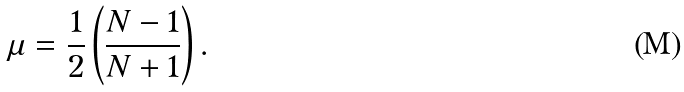Convert formula to latex. <formula><loc_0><loc_0><loc_500><loc_500>\mu = \frac { 1 } { 2 } \left ( \frac { N - 1 } { N + 1 } \right ) .</formula> 